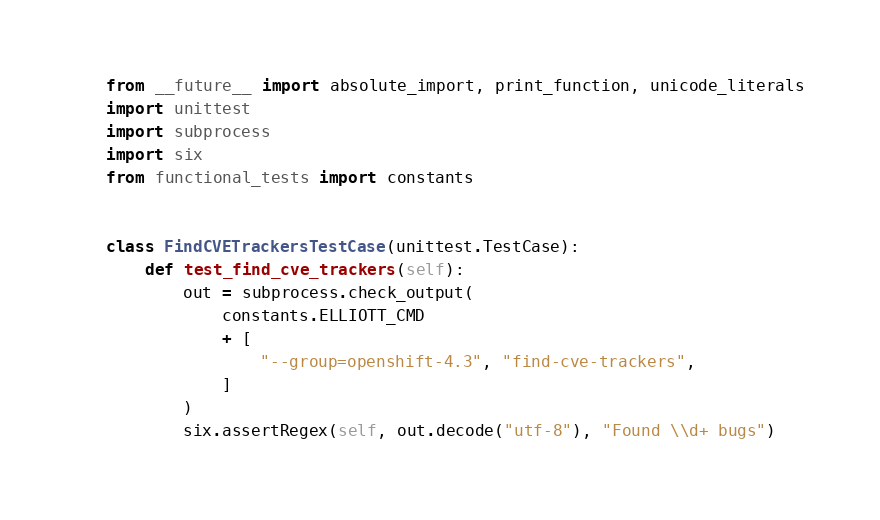Convert code to text. <code><loc_0><loc_0><loc_500><loc_500><_Python_>from __future__ import absolute_import, print_function, unicode_literals
import unittest
import subprocess
import six
from functional_tests import constants


class FindCVETrackersTestCase(unittest.TestCase):
    def test_find_cve_trackers(self):
        out = subprocess.check_output(
            constants.ELLIOTT_CMD
            + [
                "--group=openshift-4.3", "find-cve-trackers",
            ]
        )
        six.assertRegex(self, out.decode("utf-8"), "Found \\d+ bugs")
</code> 